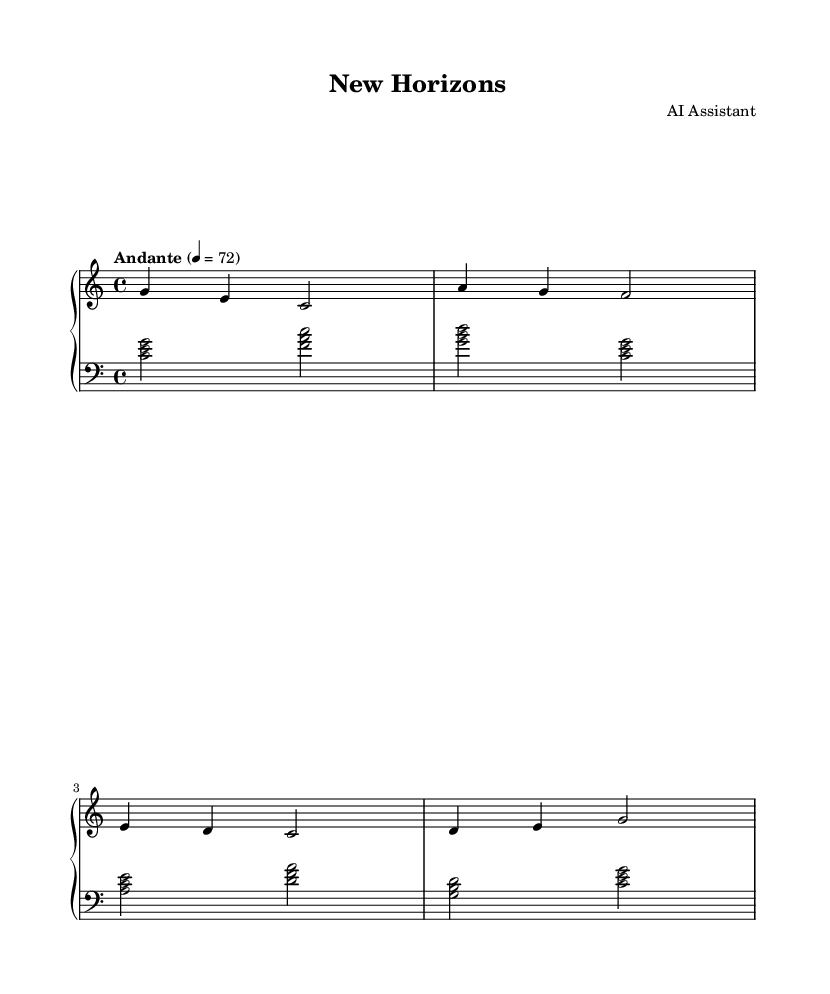What is the key signature of this music? The key signature is C major, which has no sharps or flats.
Answer: C major What is the time signature of the piece? The time signature is indicated by the fraction at the beginning of the score, which is 4/4. This means there are four beats per measure, and the quarter note gets one beat.
Answer: 4/4 What is the tempo marking of this piece? The tempo marking is given as "Andante" with a metronome marking of 72 beats per minute. "Andante" suggests a moderate pace, which is confirmed by the BPM.
Answer: Andante, 72 How many measures are there in the right hand part? Counting the segments divided by vertical lines (bar lines) in the right hand part shows there are 4 measures.
Answer: 4 What notes are played simultaneously in the first measure of the left hand? The left hand plays three notes in the first measure: C, E, and G, as shown by the chord notation. These notes form a C major chord.
Answer: C, E, G Which voice is playing the highest notes overall in this piece? By examining both hands, the right hand contains the highest notes compared to the left hand. The right hand's melody typically plays above the left hand's harmony.
Answer: Right hand What is the structure of the piece based on the left hand variations? The left hand uses a repeated pattern of chords, with each pair of measures showcasing a different chord progression typical for soothing pieces. This structure emphasizes harmonic diversity.
Answer: Chord progression 